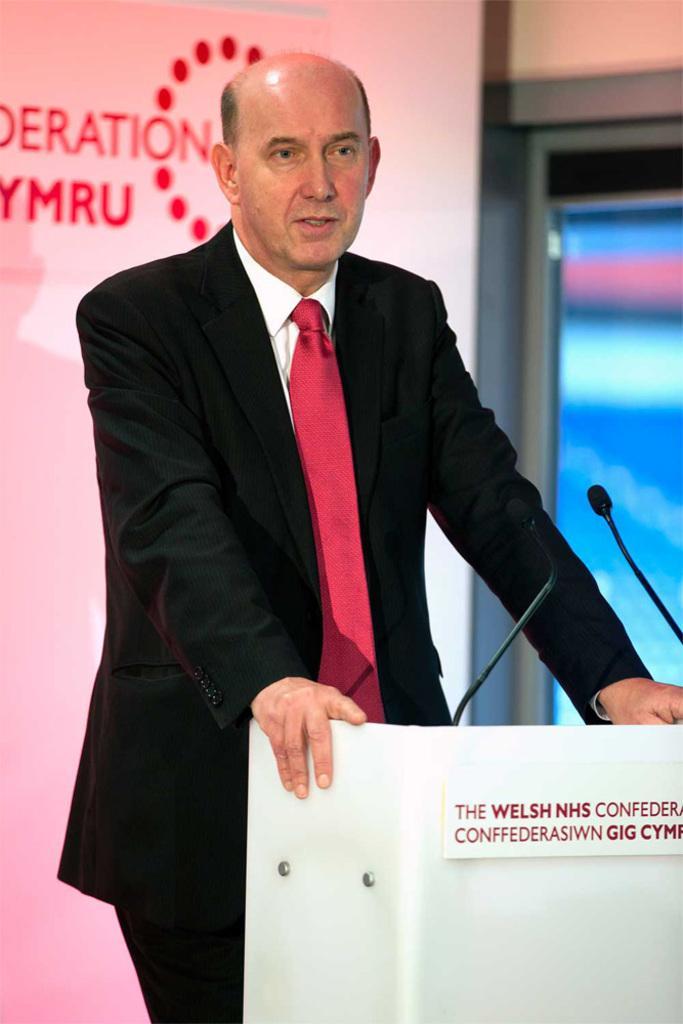How would you summarize this image in a sentence or two? In this image in the front there is a podium with some text written on it. On the top of the podium there are mics. In the center there is a person standing. In the background there is a board with some text written on it which is pink in colour and there is a glass and wall. 